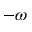<formula> <loc_0><loc_0><loc_500><loc_500>- \omega</formula> 